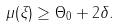<formula> <loc_0><loc_0><loc_500><loc_500>\mu ( \xi ) \geq \Theta _ { 0 } + 2 \delta .</formula> 